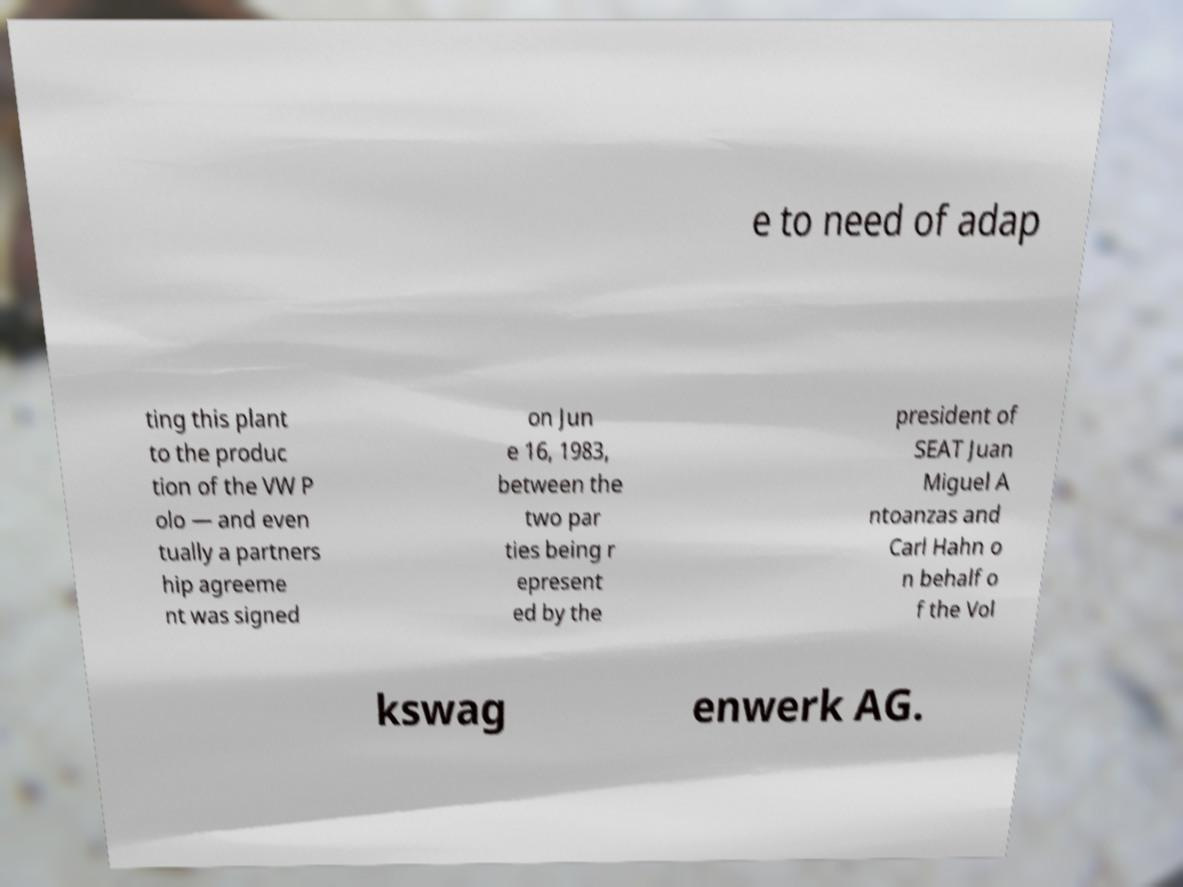Can you accurately transcribe the text from the provided image for me? e to need of adap ting this plant to the produc tion of the VW P olo — and even tually a partners hip agreeme nt was signed on Jun e 16, 1983, between the two par ties being r epresent ed by the president of SEAT Juan Miguel A ntoanzas and Carl Hahn o n behalf o f the Vol kswag enwerk AG. 